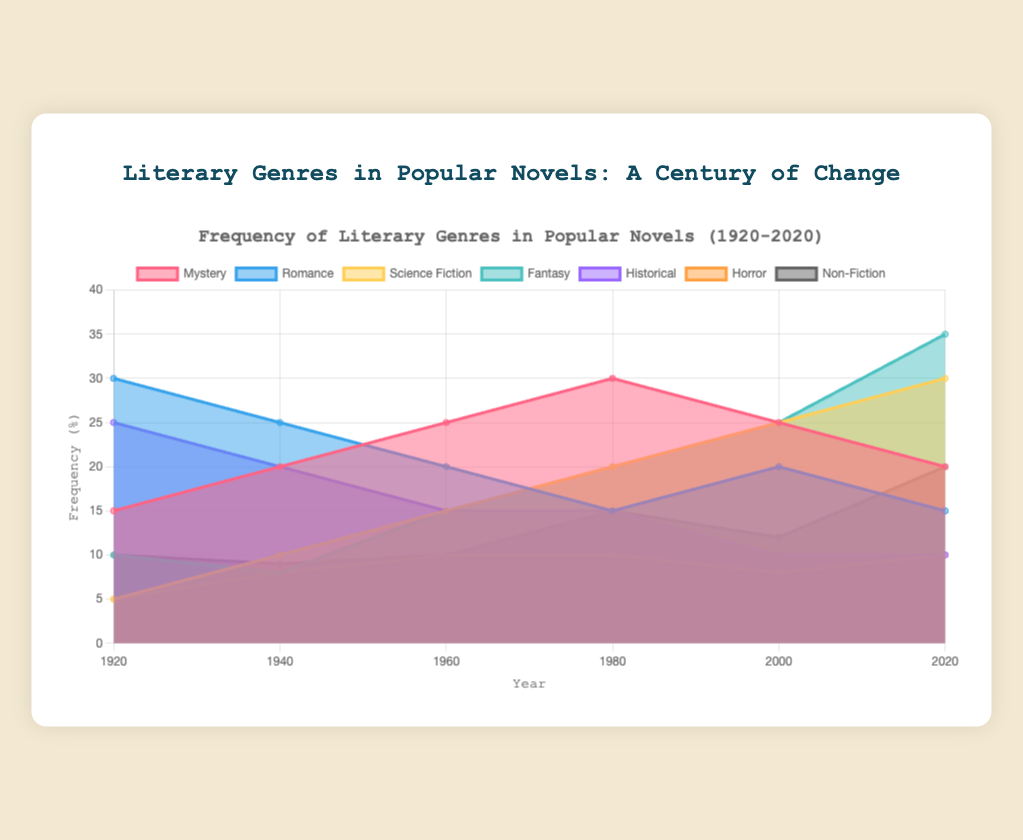What is the title of the chart? The title is located at the top of the chart and provides a brief overview of the data being presented. The chart's title reads "Frequency of Literary Genres in Popular Novels (1920-2020)".
Answer: Frequency of Literary Genres in Popular Novels (1920-2020) Which genre increased the most between 1920 and 2020? To find the genre that increased the most, look at the difference in the frequency of each genre between 1920 and 2020. Science Fiction increased from 5% to 30%, which is an increase of 25%.
Answer: Science Fiction What was the frequency of Romance novels in 1960? Find the Romance data point for the year 1960. The chart shows Romance at 20%.
Answer: 20% Which genre had the highest frequency in 1920? Compare the frequency of all the genres in the year 1920. Romance had the highest frequency at 30%.
Answer: Romance How did the frequency of Non-Fiction change from 1980 to 2020? Compare the frequency of Non-Fiction in 1980 and 2020. It increased from 15% to 20%.
Answer: +5% Which two genres had the same frequency in 2020? Look at the frequencies for the year 2020. Historical and Horror both had frequencies of 10%.
Answer: Historical and Horror What is the current trend for Fantasy novels from 1920 to 2020? Observe the frequency trend of Fantasy over the years in the chart. It showed a significant increase, particularly notable after 1980, rising from 10% in 1920 to 35% in 2020.
Answer: Increasing How did the frequency of Mystery novels change from 1980 to 2000? Look at the values for Mystery at 1980 and 2000. The frequency shows a decline from 30% to 25%.
Answer: -5% What is the total frequency of all genres in 1960? Sum up the frequencies of all genres for the year 1960: Mystery (25) + Romance (20) + Science Fiction (15) + Fantasy (15) + Historical (15) + Horror (10) + Non-Fiction (10) = 110%.
Answer: 110% Between which two consecutive decades did Science Fiction see the greatest increase? Evaluate the increases between each pair of consecutive decades for Science Fiction. The largest increase happened between 2000 (25%) and 2020 (30%), which is an increase of 5%.
Answer: 2000 and 2020 